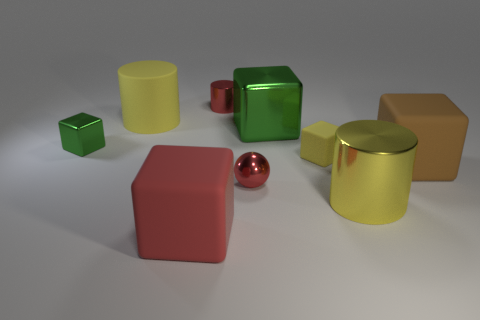Can you describe the texture of the objects in the image? Certainly! The objects in the image exhibit various textures. The yellow and large brown cubes have a matte finish with a slightly rough texture, whereas the green cube and the gold cylinder appear glossy, reflecting light smoothly. The tiny shiny red object and the red block have metallic surfaces with reflective properties, lending them a shiny, polished look. 